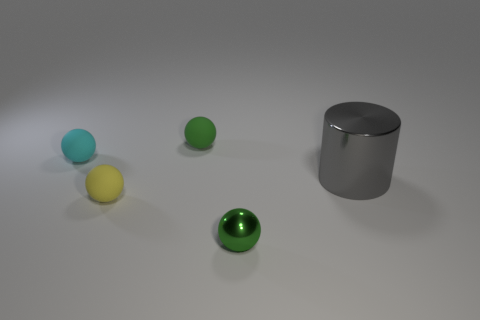What number of balls have the same color as the large cylinder?
Keep it short and to the point. 0. Do the rubber thing that is in front of the cyan rubber sphere and the cylinder have the same color?
Your response must be concise. No. The green thing that is behind the small cyan matte thing has what shape?
Your answer should be very brief. Sphere. Are there any tiny spheres that are to the left of the metallic object that is on the left side of the large gray thing?
Your response must be concise. Yes. What number of green objects have the same material as the gray object?
Offer a terse response. 1. How big is the ball that is right of the rubber object that is on the right side of the tiny yellow ball behind the tiny green shiny object?
Your answer should be very brief. Small. There is a yellow thing; how many rubber objects are behind it?
Provide a short and direct response. 2. Is the number of green objects greater than the number of small blue metallic cylinders?
Give a very brief answer. Yes. What size is the matte ball that is the same color as the tiny shiny ball?
Your answer should be very brief. Small. What size is the sphere that is to the left of the tiny green rubber thing and behind the big gray cylinder?
Your answer should be compact. Small. 